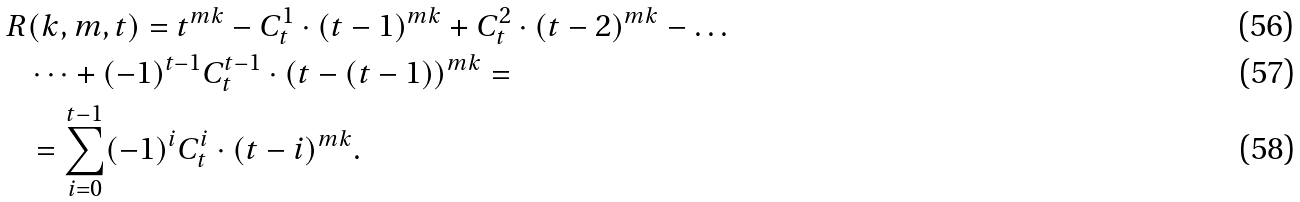Convert formula to latex. <formula><loc_0><loc_0><loc_500><loc_500>R & ( k , m , t ) = t ^ { m k } - C _ { t } ^ { 1 } \cdot ( t - 1 ) ^ { m k } + C _ { t } ^ { 2 } \cdot ( t - 2 ) ^ { m k } - \dots \\ & \dots + ( - 1 ) ^ { t - 1 } C _ { t } ^ { t - 1 } \cdot ( t - ( t - 1 ) ) ^ { m k } = \\ & = \sum _ { i = 0 } ^ { t - 1 } ( - 1 ) ^ { i } C _ { t } ^ { i } \cdot ( t - i ) ^ { m k } .</formula> 